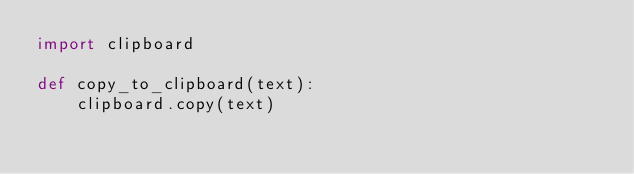<code> <loc_0><loc_0><loc_500><loc_500><_Python_>import clipboard

def copy_to_clipboard(text):
    clipboard.copy(text)</code> 